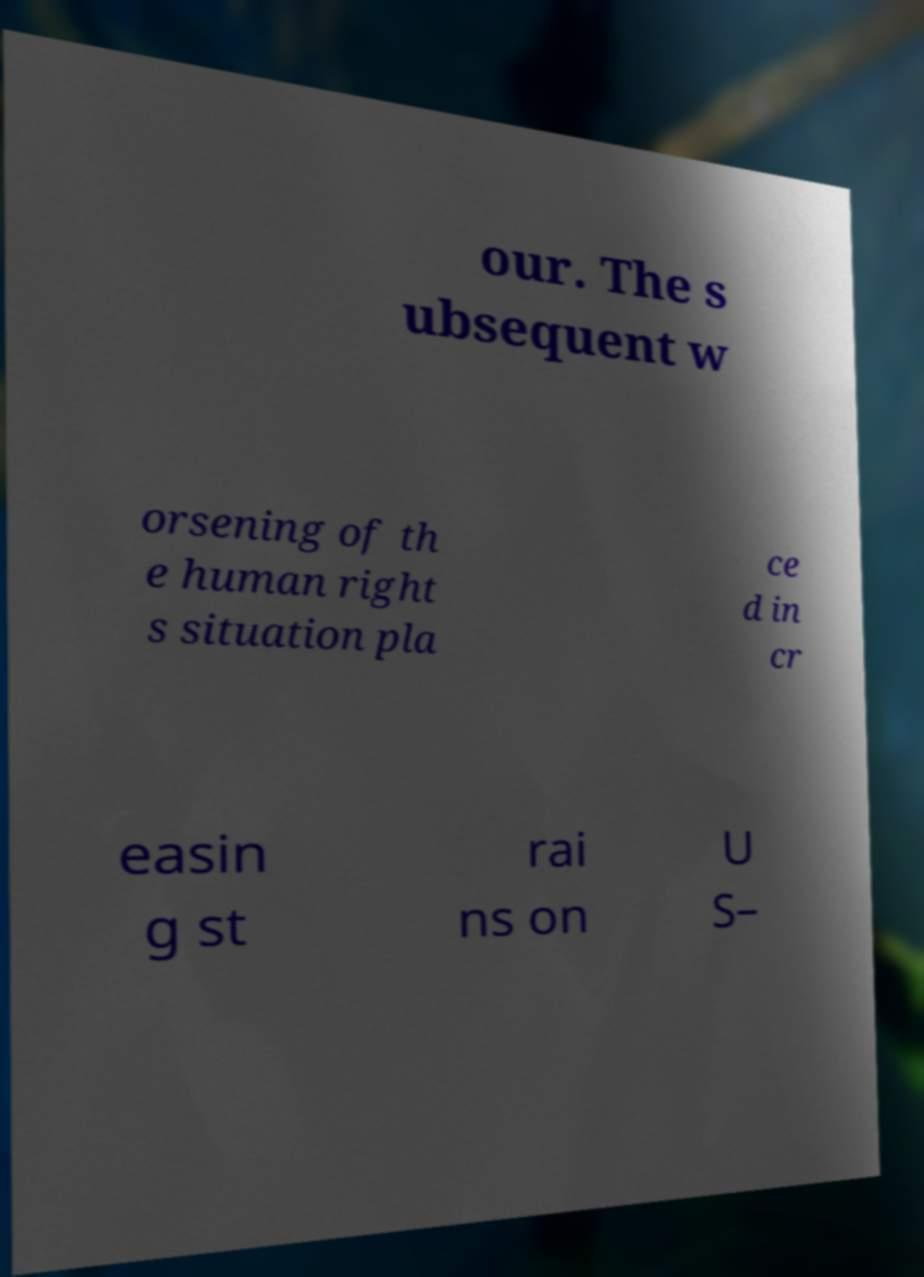Could you assist in decoding the text presented in this image and type it out clearly? our. The s ubsequent w orsening of th e human right s situation pla ce d in cr easin g st rai ns on U S– 